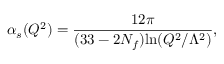<formula> <loc_0><loc_0><loc_500><loc_500>\alpha _ { s } ( Q ^ { 2 } ) = \frac { 1 2 \pi } { ( 3 3 - 2 N _ { f } ) \ln ( Q ^ { 2 } / \Lambda ^ { 2 } ) } ,</formula> 